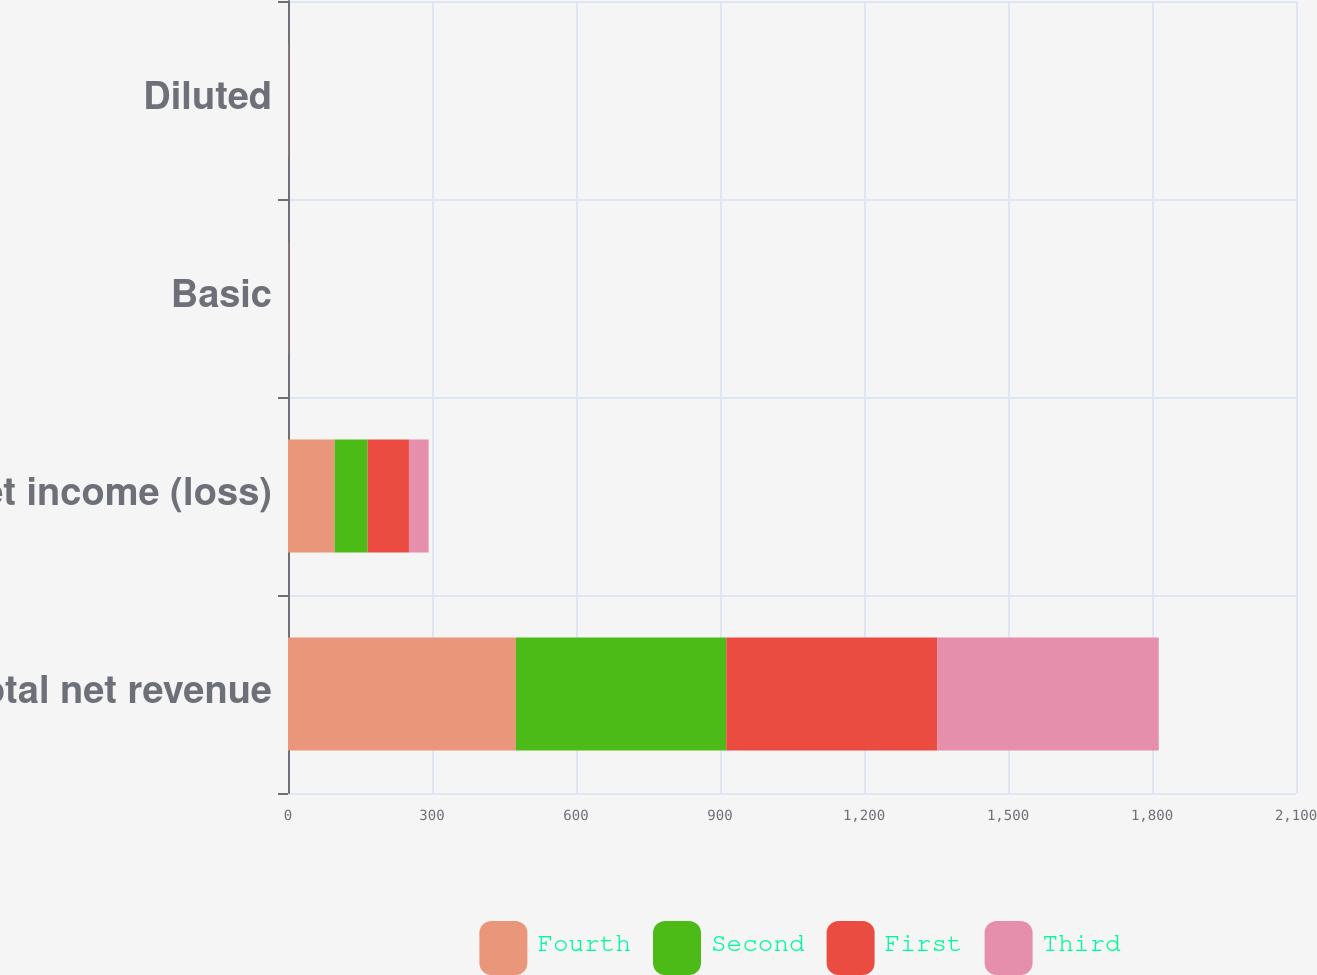Convert chart. <chart><loc_0><loc_0><loc_500><loc_500><stacked_bar_chart><ecel><fcel>Total net revenue<fcel>Net income (loss)<fcel>Basic<fcel>Diluted<nl><fcel>Fourth<fcel>475<fcel>97<fcel>0.34<fcel>0.33<nl><fcel>Second<fcel>438<fcel>69<fcel>0.24<fcel>0.24<nl><fcel>First<fcel>440<fcel>86<fcel>0.3<fcel>0.29<nl><fcel>Third<fcel>461<fcel>41<fcel>0.14<fcel>0.14<nl></chart> 